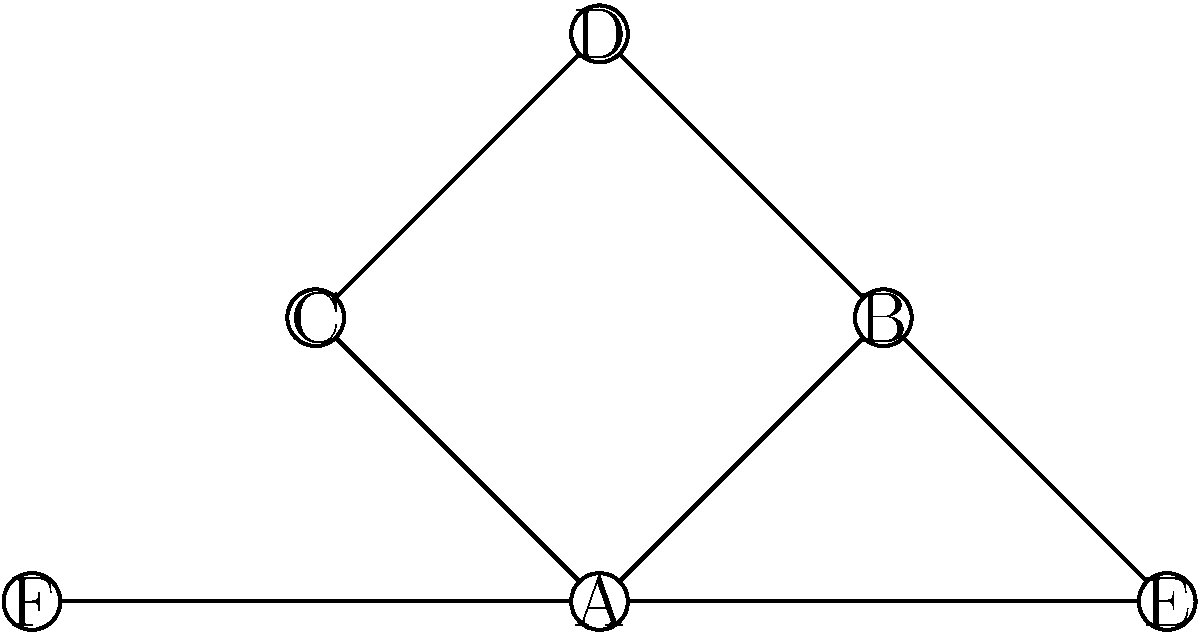In the contact network diagram above, which individual would be considered the most critical for disease transmission based on their position in the network? Explain your reasoning considering both direct and indirect connections. To determine the most critical individual for disease transmission, we need to analyze the network structure and consider both direct and indirect connections. Let's follow these steps:

1. Count direct connections (degree centrality):
   A: 4 connections
   B: 3 connections
   C: 2 connections
   D: 2 connections
   E: 2 connections
   F: 1 connection

2. Analyze indirect connections and position:
   A is connected to all other nodes either directly or through one intermediary.
   B is connected to all nodes except F, either directly or through one intermediary.
   C, D, E, and F have more limited reach in the network.

3. Consider the betweenness centrality:
   A appears in the most shortest paths between other nodes.
   B is the second most important in terms of betweenness.

4. Evaluate the overall network structure:
   A is at the center of the network, acting as a hub connecting all other nodes.
   Removing A would significantly disrupt the network connectivity.

Based on this analysis, individual A is the most critical for disease transmission because:

1. It has the highest degree centrality (most direct connections).
2. It has the highest betweenness centrality (appears in the most shortest paths).
3. It acts as a central hub, connecting all parts of the network.
4. Removing A would most significantly impair the network's connectivity and potential for disease spread.

Therefore, in an epidemiological context, targeting individual A for intervention (e.g., vaccination, isolation, or education) would likely have the most significant impact on reducing disease transmission in this network.
Answer: Individual A 